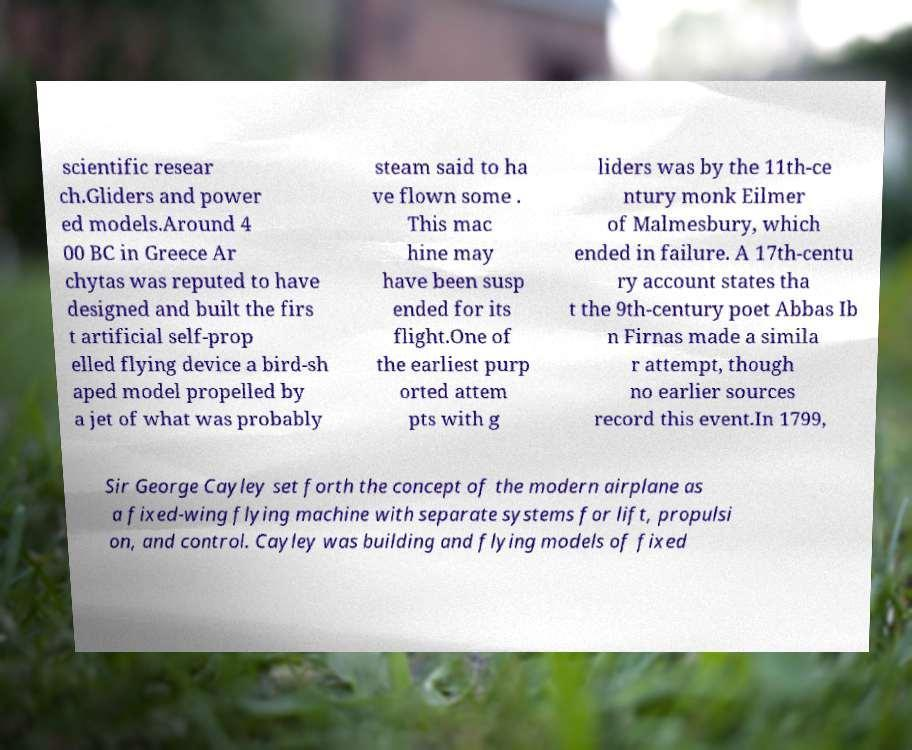Can you read and provide the text displayed in the image?This photo seems to have some interesting text. Can you extract and type it out for me? scientific resear ch.Gliders and power ed models.Around 4 00 BC in Greece Ar chytas was reputed to have designed and built the firs t artificial self-prop elled flying device a bird-sh aped model propelled by a jet of what was probably steam said to ha ve flown some . This mac hine may have been susp ended for its flight.One of the earliest purp orted attem pts with g liders was by the 11th-ce ntury monk Eilmer of Malmesbury, which ended in failure. A 17th-centu ry account states tha t the 9th-century poet Abbas Ib n Firnas made a simila r attempt, though no earlier sources record this event.In 1799, Sir George Cayley set forth the concept of the modern airplane as a fixed-wing flying machine with separate systems for lift, propulsi on, and control. Cayley was building and flying models of fixed 